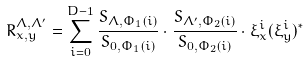<formula> <loc_0><loc_0><loc_500><loc_500>R _ { x , y } ^ { \Lambda , \Lambda ^ { \prime } } = \sum _ { i = 0 } ^ { D - 1 } \frac { S _ { \Lambda , \Phi _ { 1 } ( i ) } } { S _ { 0 , \Phi _ { 1 } ( i ) } } \cdot \frac { S _ { \Lambda ^ { \prime } , \Phi _ { 2 } ( i ) } } { S _ { 0 , \Phi _ { 2 } ( i ) } } \cdot \xi _ { x } ^ { i } ( \xi _ { y } ^ { i } ) ^ { * }</formula> 